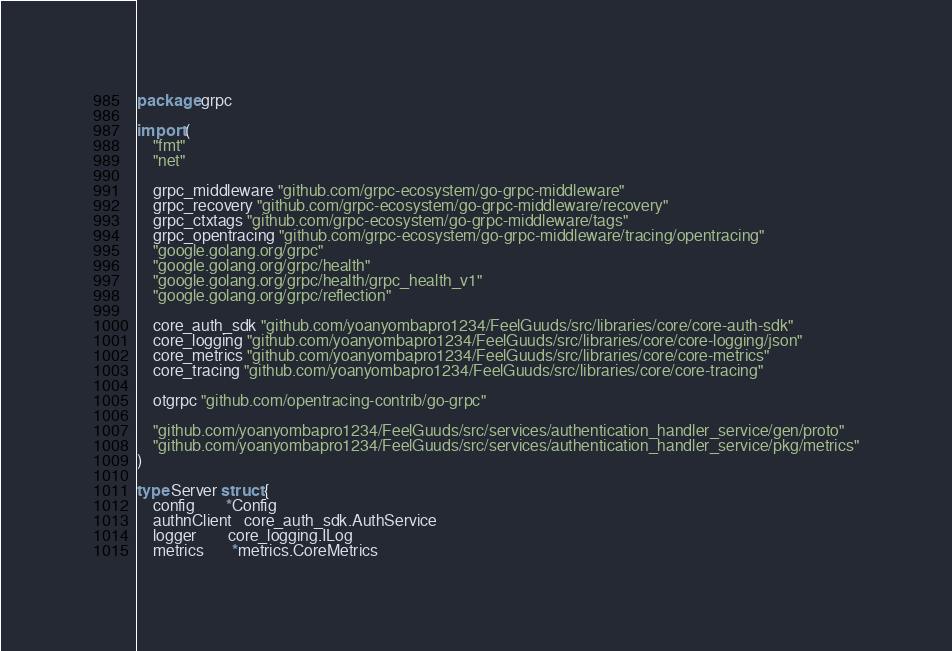<code> <loc_0><loc_0><loc_500><loc_500><_Go_>package grpc

import (
	"fmt"
	"net"

	grpc_middleware "github.com/grpc-ecosystem/go-grpc-middleware"
	grpc_recovery "github.com/grpc-ecosystem/go-grpc-middleware/recovery"
	grpc_ctxtags "github.com/grpc-ecosystem/go-grpc-middleware/tags"
	grpc_opentracing "github.com/grpc-ecosystem/go-grpc-middleware/tracing/opentracing"
	"google.golang.org/grpc"
	"google.golang.org/grpc/health"
	"google.golang.org/grpc/health/grpc_health_v1"
	"google.golang.org/grpc/reflection"

	core_auth_sdk "github.com/yoanyombapro1234/FeelGuuds/src/libraries/core/core-auth-sdk"
	core_logging "github.com/yoanyombapro1234/FeelGuuds/src/libraries/core/core-logging/json"
	core_metrics "github.com/yoanyombapro1234/FeelGuuds/src/libraries/core/core-metrics"
	core_tracing "github.com/yoanyombapro1234/FeelGuuds/src/libraries/core/core-tracing"

	otgrpc "github.com/opentracing-contrib/go-grpc"

	"github.com/yoanyombapro1234/FeelGuuds/src/services/authentication_handler_service/gen/proto"
	"github.com/yoanyombapro1234/FeelGuuds/src/services/authentication_handler_service/pkg/metrics"
)

type Server struct {
	config        *Config
	authnClient   core_auth_sdk.AuthService
	logger        core_logging.ILog
	metrics       *metrics.CoreMetrics</code> 